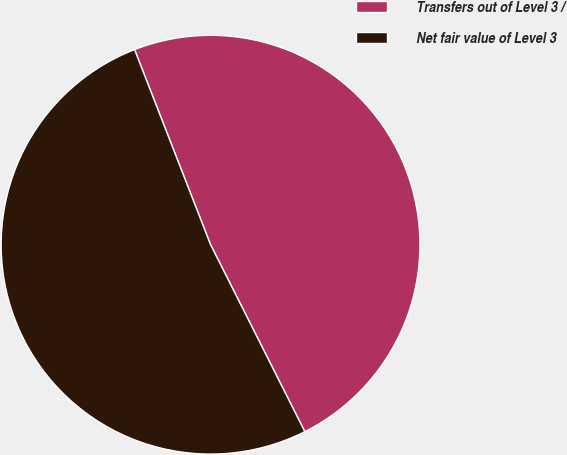Convert chart to OTSL. <chart><loc_0><loc_0><loc_500><loc_500><pie_chart><fcel>Transfers out of Level 3 /<fcel>Net fair value of Level 3<nl><fcel>48.48%<fcel>51.52%<nl></chart> 